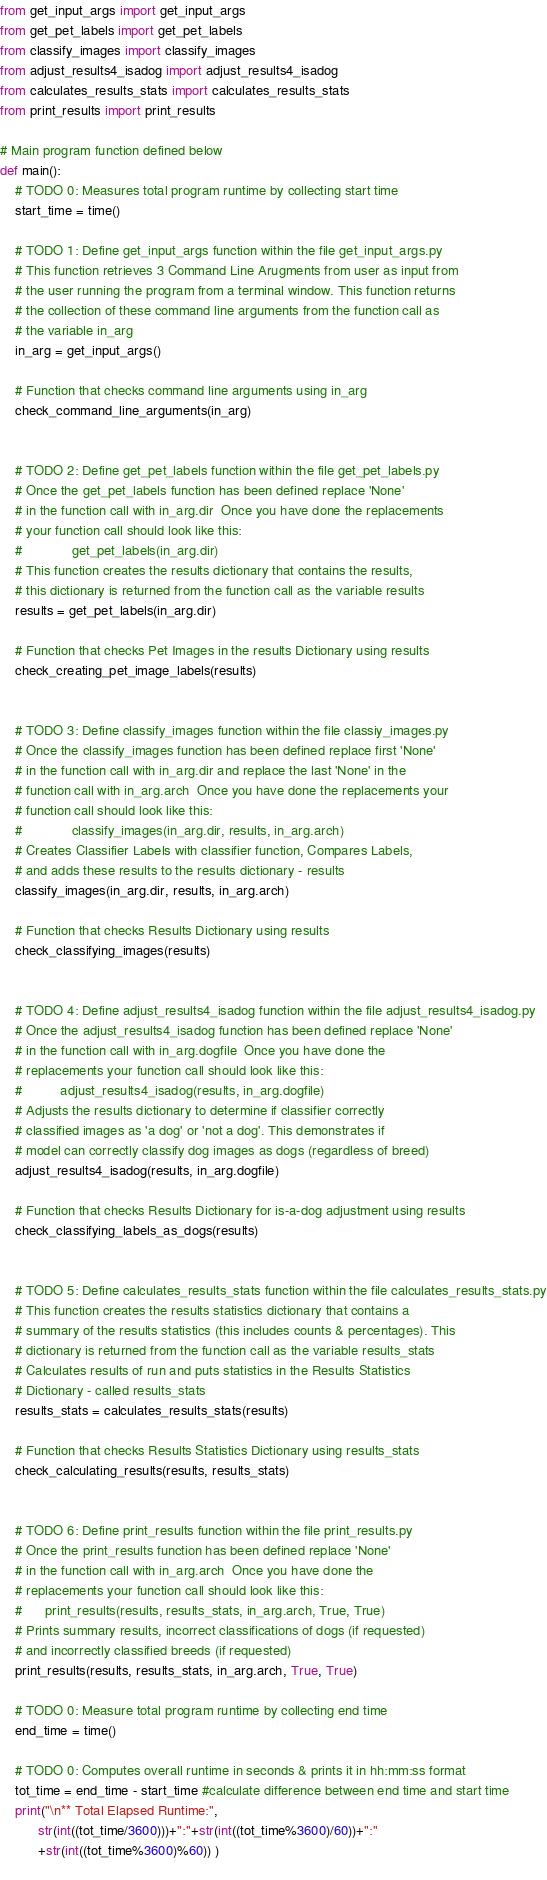<code> <loc_0><loc_0><loc_500><loc_500><_Python_>from get_input_args import get_input_args
from get_pet_labels import get_pet_labels
from classify_images import classify_images
from adjust_results4_isadog import adjust_results4_isadog
from calculates_results_stats import calculates_results_stats
from print_results import print_results

# Main program function defined below
def main():
    # TODO 0: Measures total program runtime by collecting start time
    start_time = time()
    
    # TODO 1: Define get_input_args function within the file get_input_args.py
    # This function retrieves 3 Command Line Arugments from user as input from
    # the user running the program from a terminal window. This function returns
    # the collection of these command line arguments from the function call as
    # the variable in_arg
    in_arg = get_input_args()

    # Function that checks command line arguments using in_arg  
    check_command_line_arguments(in_arg)

    
    # TODO 2: Define get_pet_labels function within the file get_pet_labels.py
    # Once the get_pet_labels function has been defined replace 'None' 
    # in the function call with in_arg.dir  Once you have done the replacements
    # your function call should look like this: 
    #             get_pet_labels(in_arg.dir)
    # This function creates the results dictionary that contains the results, 
    # this dictionary is returned from the function call as the variable results
    results = get_pet_labels(in_arg.dir)

    # Function that checks Pet Images in the results Dictionary using results    
    check_creating_pet_image_labels(results)


    # TODO 3: Define classify_images function within the file classiy_images.py
    # Once the classify_images function has been defined replace first 'None' 
    # in the function call with in_arg.dir and replace the last 'None' in the
    # function call with in_arg.arch  Once you have done the replacements your
    # function call should look like this: 
    #             classify_images(in_arg.dir, results, in_arg.arch)
    # Creates Classifier Labels with classifier function, Compares Labels, 
    # and adds these results to the results dictionary - results
    classify_images(in_arg.dir, results, in_arg.arch)

    # Function that checks Results Dictionary using results    
    check_classifying_images(results)    

    
    # TODO 4: Define adjust_results4_isadog function within the file adjust_results4_isadog.py
    # Once the adjust_results4_isadog function has been defined replace 'None' 
    # in the function call with in_arg.dogfile  Once you have done the 
    # replacements your function call should look like this: 
    #          adjust_results4_isadog(results, in_arg.dogfile)
    # Adjusts the results dictionary to determine if classifier correctly 
    # classified images as 'a dog' or 'not a dog'. This demonstrates if 
    # model can correctly classify dog images as dogs (regardless of breed)
    adjust_results4_isadog(results, in_arg.dogfile)

    # Function that checks Results Dictionary for is-a-dog adjustment using results
    check_classifying_labels_as_dogs(results)


    # TODO 5: Define calculates_results_stats function within the file calculates_results_stats.py
    # This function creates the results statistics dictionary that contains a
    # summary of the results statistics (this includes counts & percentages). This
    # dictionary is returned from the function call as the variable results_stats    
    # Calculates results of run and puts statistics in the Results Statistics
    # Dictionary - called results_stats
    results_stats = calculates_results_stats(results)

    # Function that checks Results Statistics Dictionary using results_stats
    check_calculating_results(results, results_stats)


    # TODO 6: Define print_results function within the file print_results.py
    # Once the print_results function has been defined replace 'None' 
    # in the function call with in_arg.arch  Once you have done the 
    # replacements your function call should look like this: 
    #      print_results(results, results_stats, in_arg.arch, True, True)
    # Prints summary results, incorrect classifications of dogs (if requested)
    # and incorrectly classified breeds (if requested)
    print_results(results, results_stats, in_arg.arch, True, True)
    
    # TODO 0: Measure total program runtime by collecting end time
    end_time = time()
    
    # TODO 0: Computes overall runtime in seconds & prints it in hh:mm:ss format
    tot_time = end_time - start_time #calculate difference between end time and start time
    print("\n** Total Elapsed Runtime:",
          str(int((tot_time/3600)))+":"+str(int((tot_time%3600)/60))+":"
          +str(int((tot_time%3600)%60)) )
    
</code> 